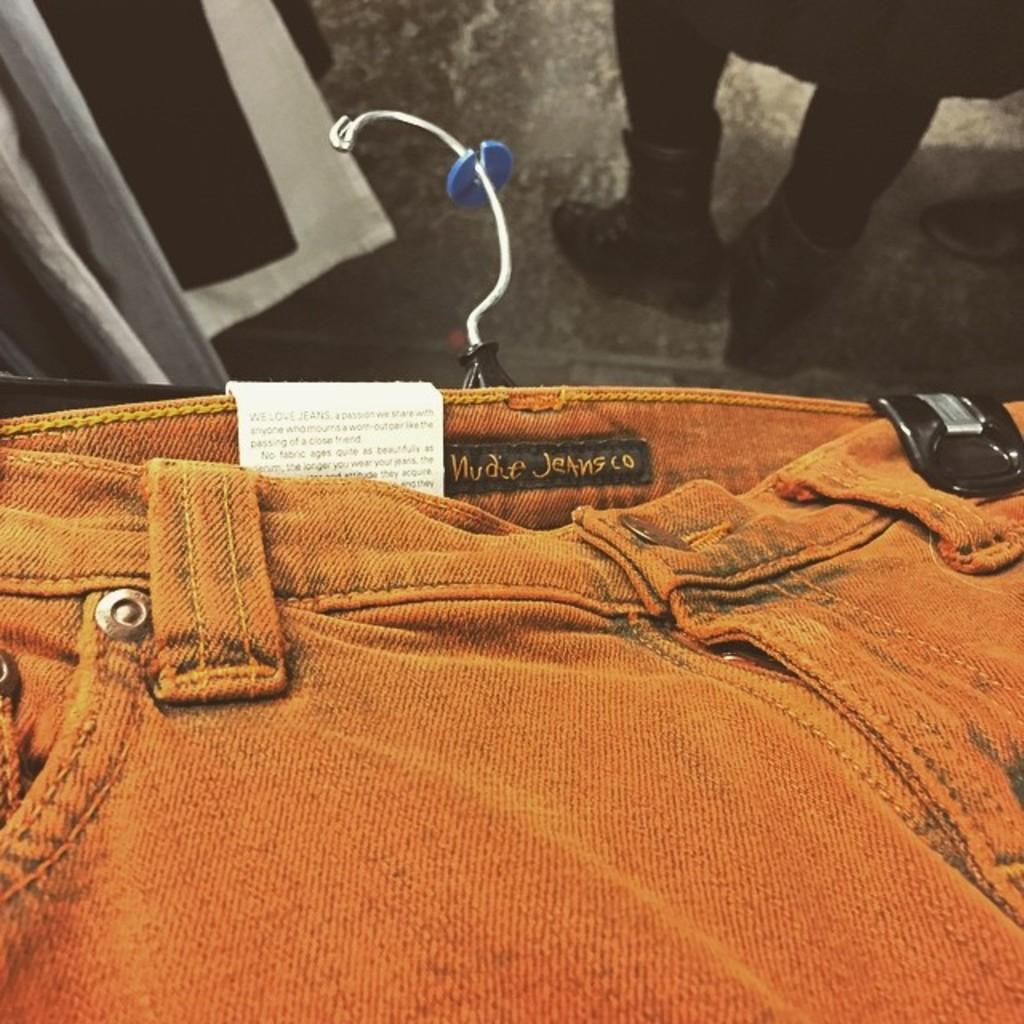What type of clothing item is present in the image? There is a jeans trouser in the image. What is the cause of the jeans trouser's digestion in the image? There is no mention of digestion in the image, as it features a jeans trouser and not a living organism. 